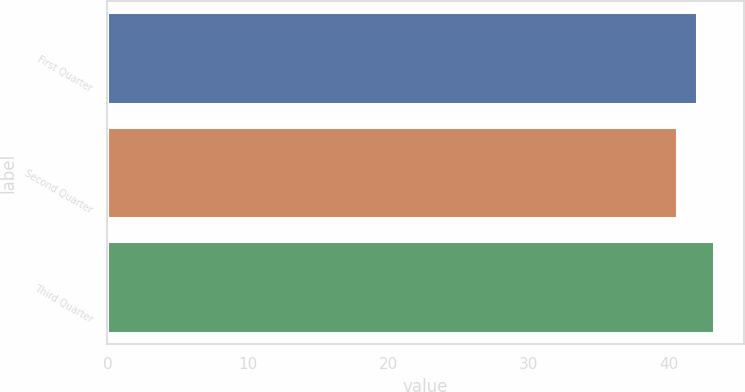<chart> <loc_0><loc_0><loc_500><loc_500><bar_chart><fcel>First Quarter<fcel>Second Quarter<fcel>Third Quarter<nl><fcel>42<fcel>40.57<fcel>43.15<nl></chart> 